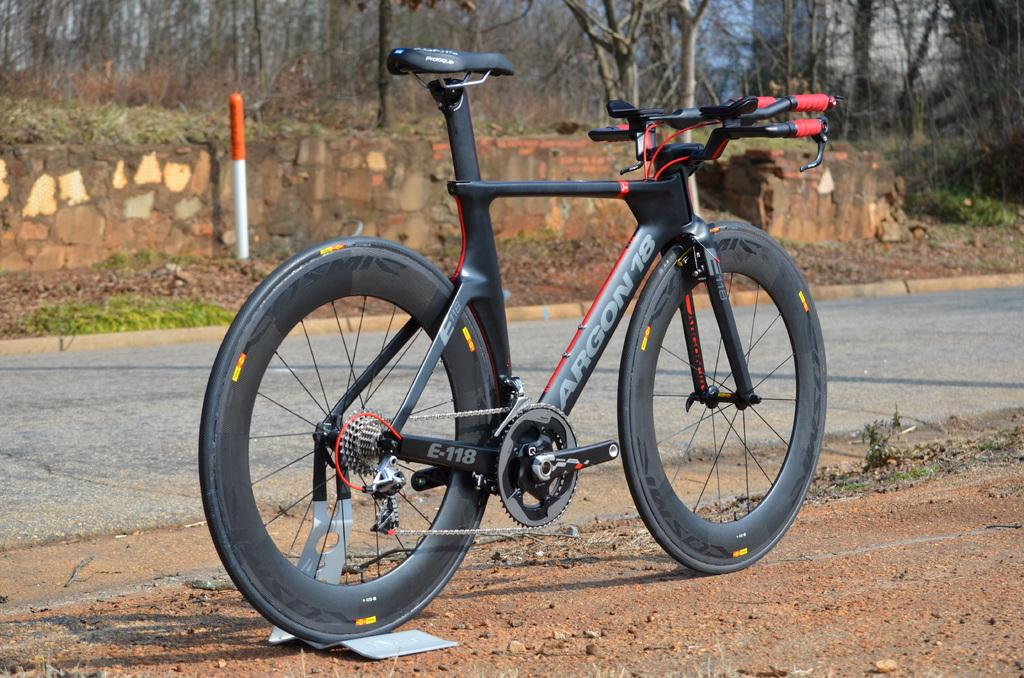What type of vehicle is in the image? There is a bicycle with a stand in the image. How is the bicycle positioned in the image? The bicycle is parked on the ground. What can be seen in the background of the image? There is a road, a pole, plants, trees, and a wall in the background of the image. What color is the orange that the bicycle is holding in the image? There is no orange present in the image; it is a bicycle with a stand parked on the ground. Can you tell me how many partners are visible in the image? There are no partners present in the image; it features a bicycle with a stand and various background elements. 